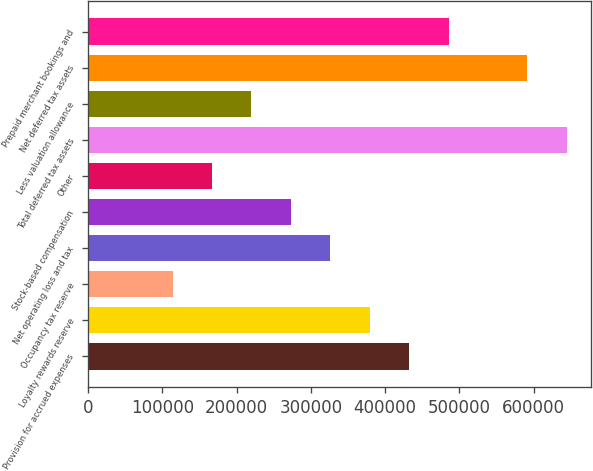Convert chart. <chart><loc_0><loc_0><loc_500><loc_500><bar_chart><fcel>Provision for accrued expenses<fcel>Loyalty rewards reserve<fcel>Occupancy tax reserve<fcel>Net operating loss and tax<fcel>Stock-based compensation<fcel>Other<fcel>Total deferred tax assets<fcel>Less valuation allowance<fcel>Net deferred tax assets<fcel>Prepaid merchant bookings and<nl><fcel>432216<fcel>379178<fcel>113989<fcel>326140<fcel>273102<fcel>167027<fcel>644368<fcel>220065<fcel>591330<fcel>485254<nl></chart> 